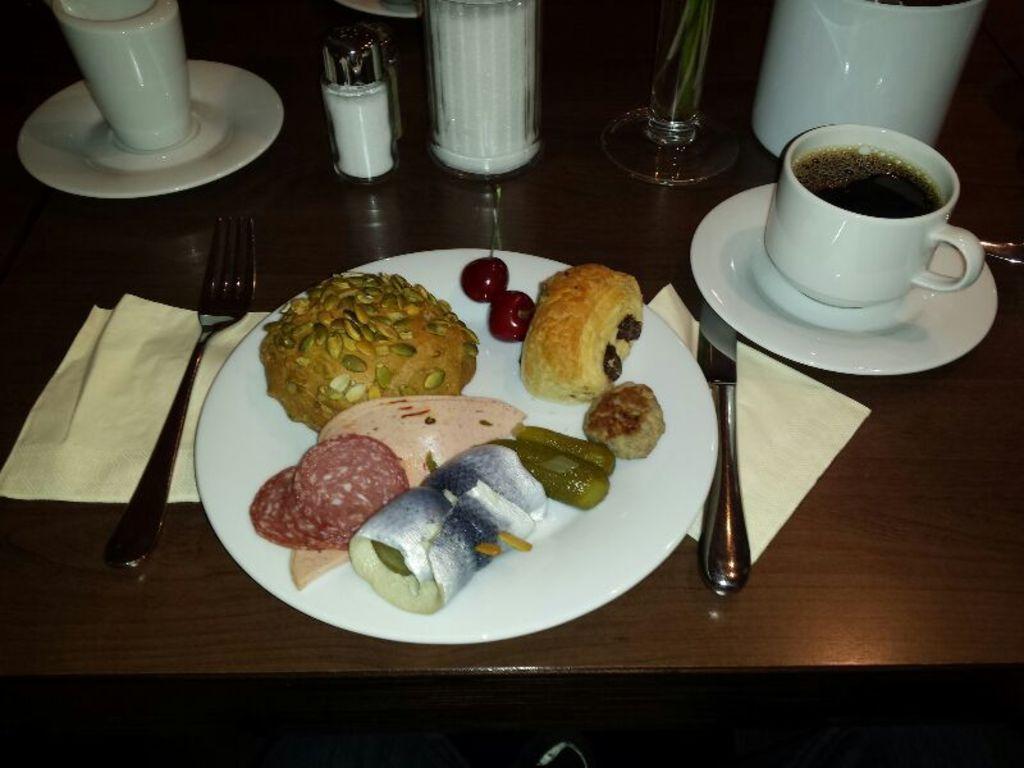Describe this image in one or two sentences. In this picture we can see some food items like bun, cherries, puff over a plate and beside to that plate we have knife, fork placed on a tissue papers and on right side we have saucer, cup full of drink and we have salt bottle and i think this is a glass placed again on a saucer and a whole is the table where all this items are placed. 